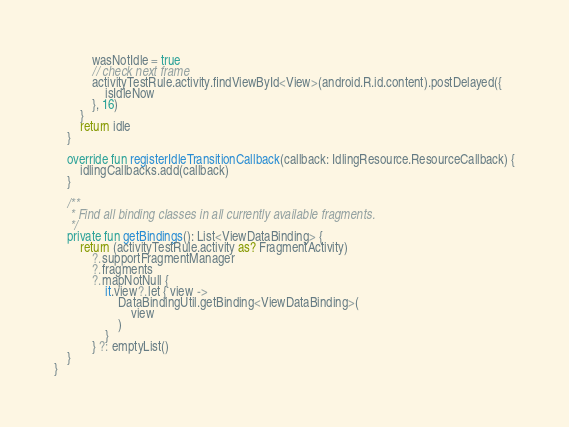Convert code to text. <code><loc_0><loc_0><loc_500><loc_500><_Kotlin_>            wasNotIdle = true
            // check next frame
            activityTestRule.activity.findViewById<View>(android.R.id.content).postDelayed({
                isIdleNow
            }, 16)
        }
        return idle
    }

    override fun registerIdleTransitionCallback(callback: IdlingResource.ResourceCallback) {
        idlingCallbacks.add(callback)
    }

    /**
     * Find all binding classes in all currently available fragments.
     */
    private fun getBindings(): List<ViewDataBinding> {
        return (activityTestRule.activity as? FragmentActivity)
            ?.supportFragmentManager
            ?.fragments
            ?.mapNotNull {
                it.view?.let { view ->
                    DataBindingUtil.getBinding<ViewDataBinding>(
                        view
                    )
                }
            } ?: emptyList()
    }
}</code> 